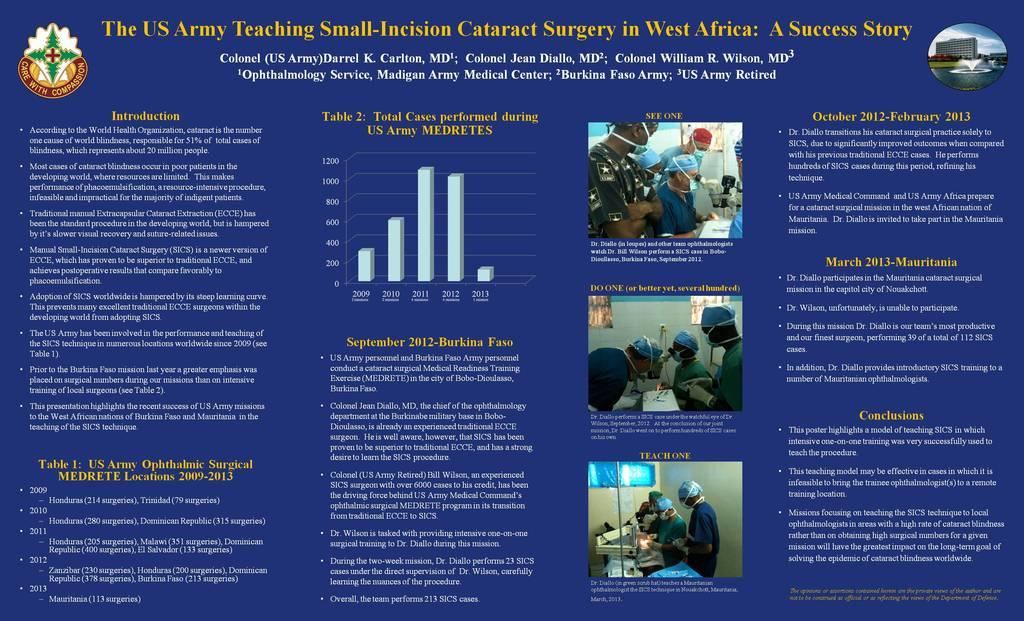What types of items can be seen in the image? There are different types of articles in the image. Can you describe the pictures on the right side of the image? There are three pictures of people on the right side of the image. Is there a horse in any of the pictures on the right side of the image? No, there is no horse present in any of the pictures on the right side of the image. 